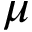Convert formula to latex. <formula><loc_0><loc_0><loc_500><loc_500>\mu</formula> 